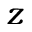<formula> <loc_0><loc_0><loc_500><loc_500>z</formula> 